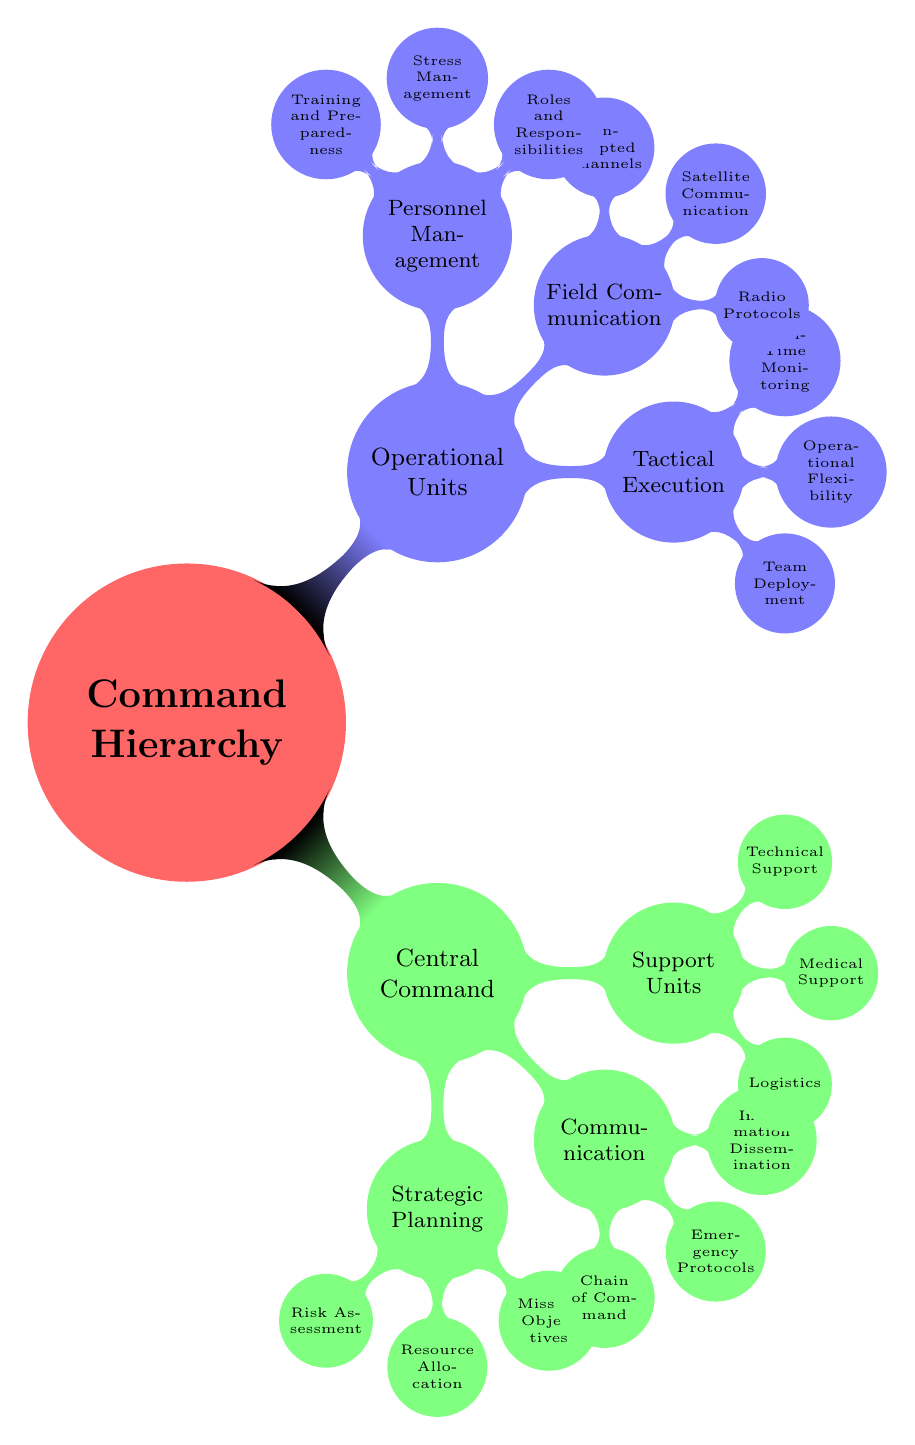What are the three main components under Central Command? The diagram shows that under Central Command, there are three main components: Strategic Planning, Communication, and Support Units.
Answer: Strategic Planning, Communication, Support Units How many sub-components are there under Tactical Execution? In the diagram, Tactical Execution has three sub-components which are Team Deployment, Operational Flexibility, and Real-Time Monitoring.
Answer: 3 What is one sub-component of Support Units? The diagram lists three sub-components under Support Units, one of which is Logistics.
Answer: Logistics Which unit includes Roles and Responsibilities? According to the diagram, Roles and Responsibilities is a sub-component of Personnel Management, which falls under Operational Units.
Answer: Personnel Management What type of communication is emphasized in the Operational Units section? The Operational Units section illustrates field communication, specifically highlighting Radio Protocols, Satellite Communication, and Encrypted Channels.
Answer: Field Communication What relationship exists between Central Command and Operational Units? The diagram indicates that Central Command and Operational Units are both primary branches of the Command Hierarchy, suggesting a structural relationship where Central Command oversees Operational Units.
Answer: Overseeing relationship How many nodes are connected to the Communication component? The Communication component includes three nodes, which are Chain of Command, Emergency Protocols, and Information Dissemination.
Answer: 3 Which component deals with real-time data? The Tactical Execution component deals with real-time data, specifically showcased through the sub-component Real-Time Monitoring.
Answer: Tactical Execution What is the primary focus of Strategic Planning? The Strategic Planning section is primarily focused on assessing risk, allocating resources, and defining mission objectives, as indicated by its three sub-components.
Answer: Assessing risk, allocating resources, defining mission objectives Which branch includes Medical Support? Medical Support is categorized under the Support Units branch of the Central Command in the diagram.
Answer: Support Units 